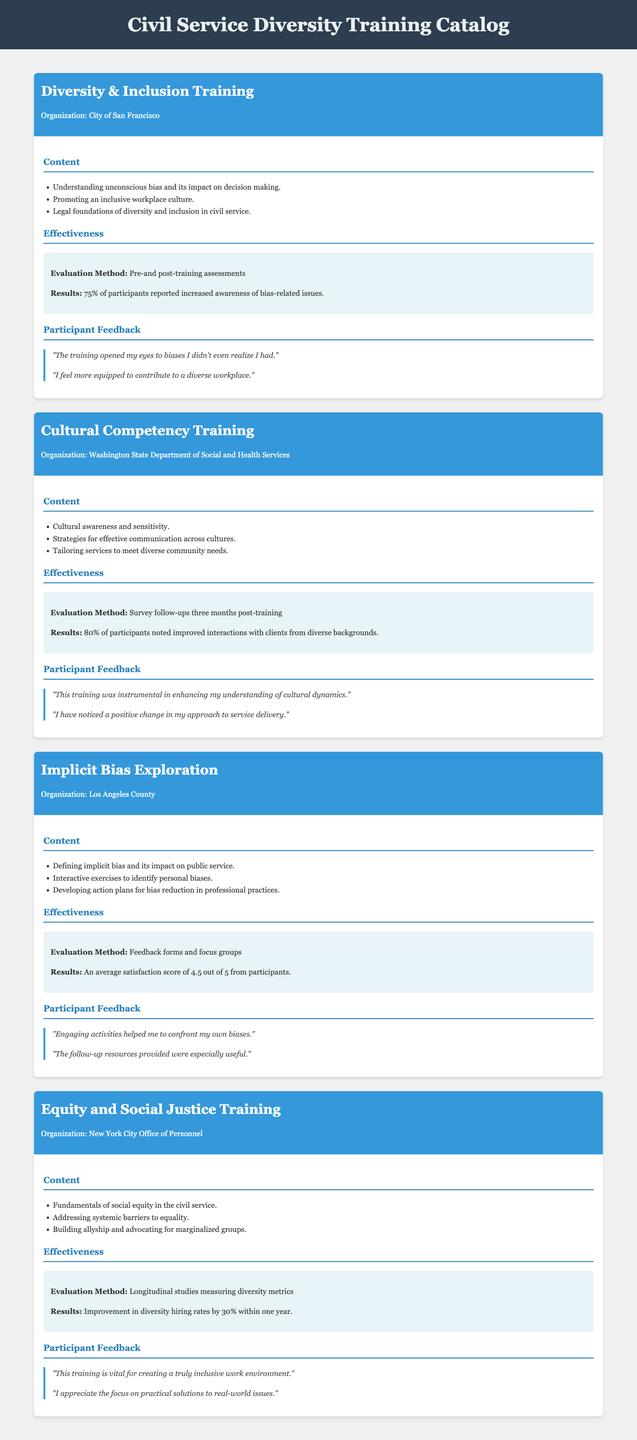What is the title of the first training program? The title of the first training program is the name mentioned at the top of the program section.
Answer: Diversity & Inclusion Training What organization conducted the Cultural Competency Training? The organization is identified in the program header for each training program.
Answer: Washington State Department of Social and Health Services What percentage of participants in the Implicit Bias Exploration reported satisfaction? The satisfaction score is mentioned in the effectiveness section of the program description.
Answer: 4.5 out of 5 What was the improvement in diversity hiring rates after the Equity and Social Justice Training? This information is found in the effectiveness section related to results of the training.
Answer: 30% What is one focus area of the Diversity & Inclusion Training? Focus areas are listed in the content section of each program.
Answer: Understanding unconscious bias and its impact on decision making How often were survey follow-ups conducted for the Cultural Competency Training? This is specified in the effectiveness section regarding evaluation methods.
Answer: Three months post-training What type of training program had interactive exercises? The program description includes this information under the content section.
Answer: Implicit Bias Exploration What underlying theme does the Equity and Social Justice Training address? The theme is indicated in the content list under each program description.
Answer: Addressing systemic barriers to equality What method was used to evaluate the Diversity & Inclusion Training? The evaluation method is stated in the effectiveness section for each program.
Answer: Pre-and post-training assessments 